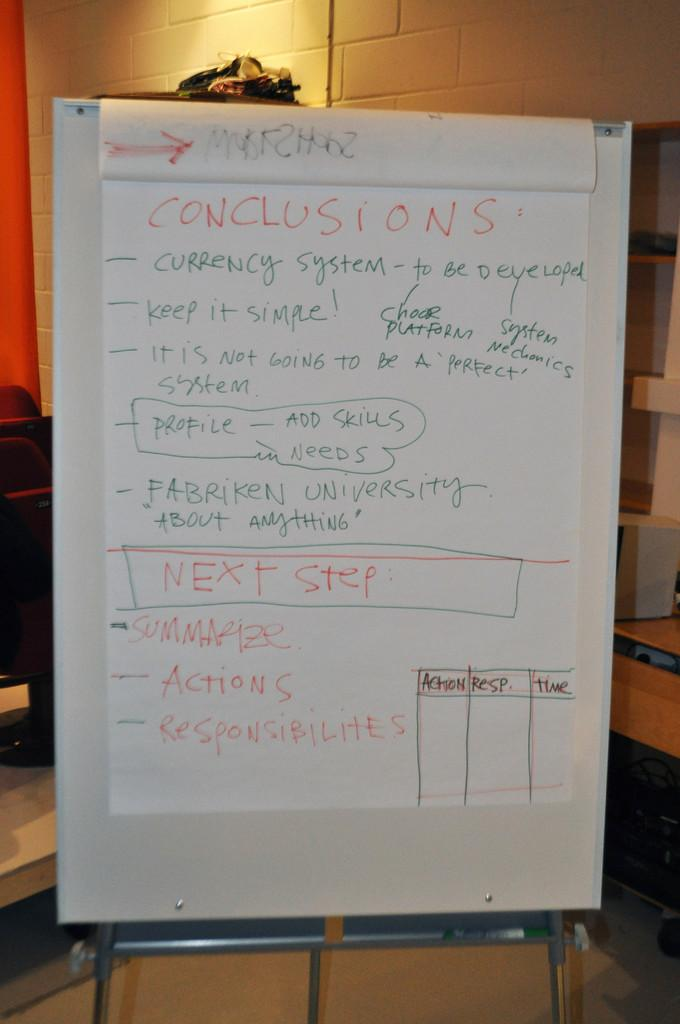Provide a one-sentence caption for the provided image. A large piece of paper covered in red, green and orange writing, the top word being CONCLUSIONS. 